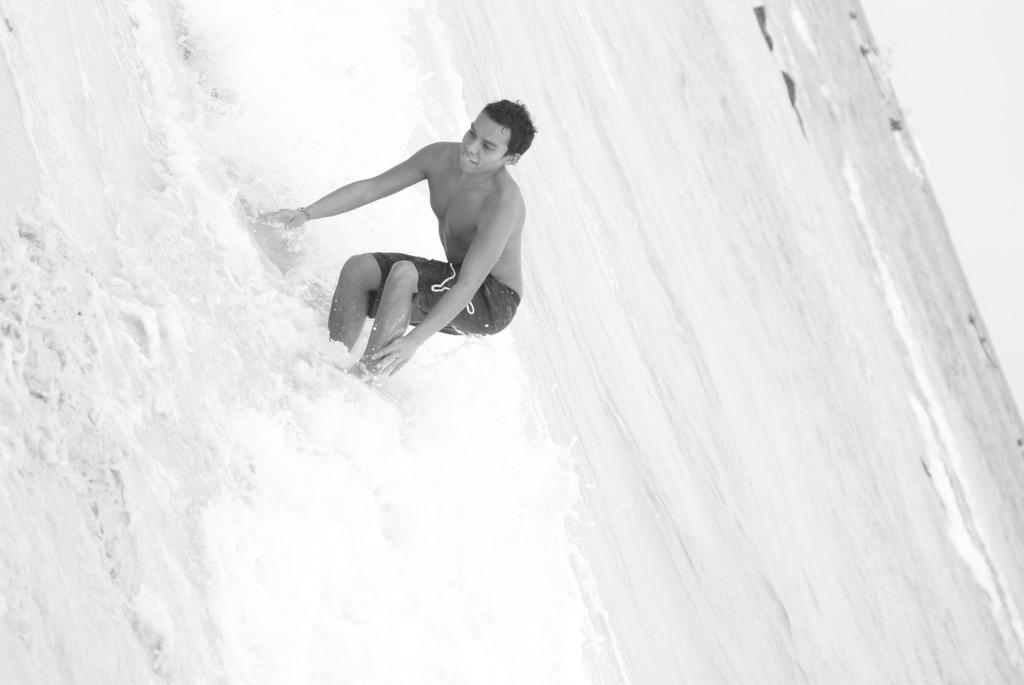Could you give a brief overview of what you see in this image? In this picture we can see a person in water. Waves are visible in water. 